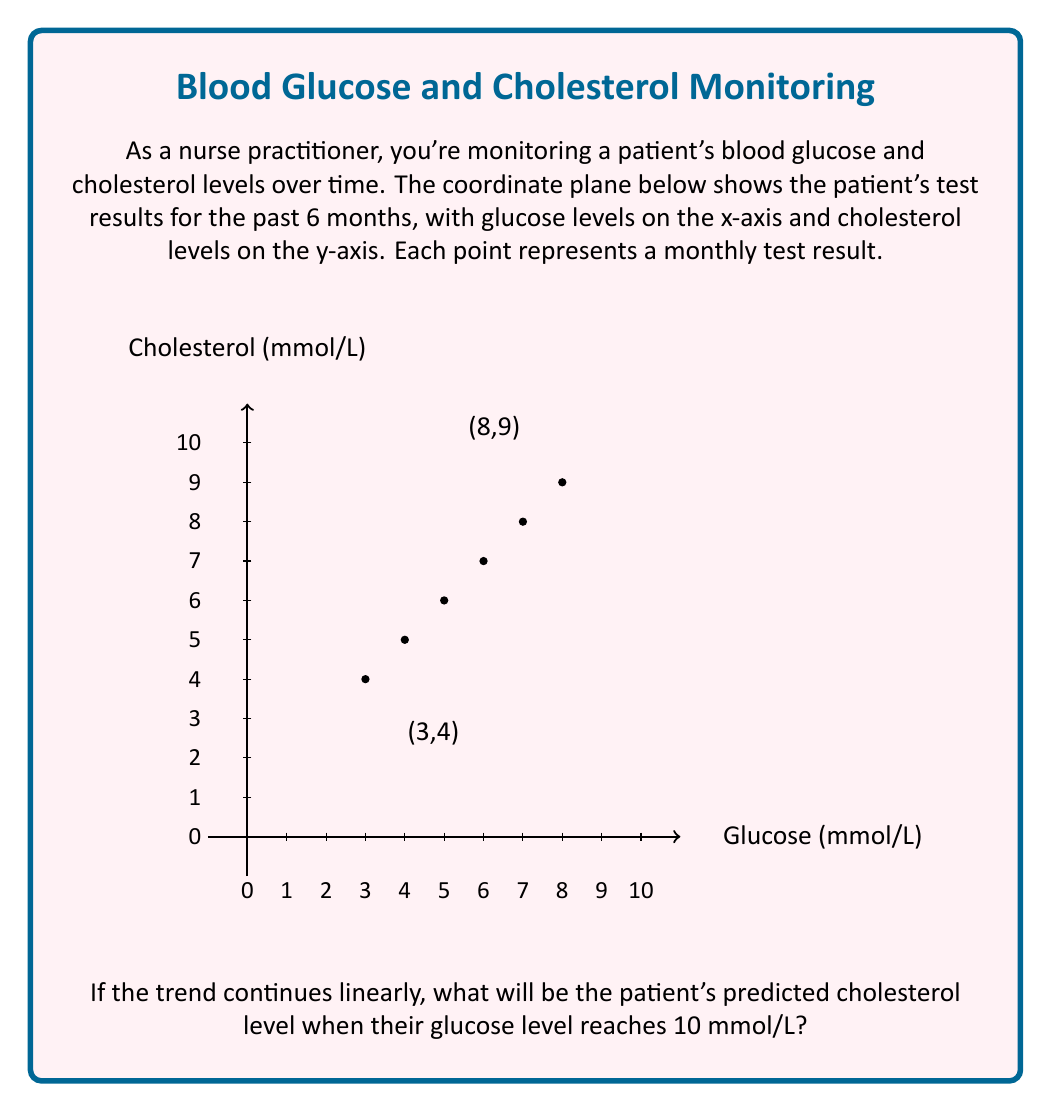Give your solution to this math problem. To solve this problem, we need to follow these steps:

1. Identify the linear trend in the data points.
2. Calculate the slope of the line.
3. Use the point-slope form of a line to find the equation.
4. Use the equation to predict the cholesterol level at a glucose level of 10 mmol/L.

Step 1: We can see that the points form a linear pattern from (3,4) to (8,9).

Step 2: Calculate the slope:
$$ m = \frac{y_2 - y_1}{x_2 - x_1} = \frac{9 - 4}{8 - 3} = \frac{5}{5} = 1 $$

Step 3: Use the point-slope form of a line: $y - y_1 = m(x - x_1)$
Let's use the point (3,4):
$$ y - 4 = 1(x - 3) $$
Simplify to slope-intercept form:
$$ y = x - 3 + 4 $$
$$ y = x + 1 $$

Step 4: Predict cholesterol level when glucose is 10 mmol/L:
$$ y = 10 + 1 = 11 $$

Therefore, if the trend continues linearly, when the glucose level is 10 mmol/L, the predicted cholesterol level will be 11 mmol/L.
Answer: 11 mmol/L 